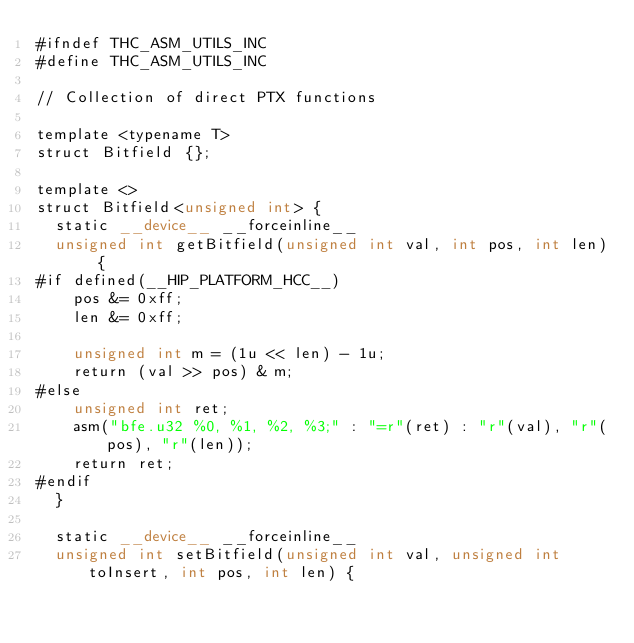Convert code to text. <code><loc_0><loc_0><loc_500><loc_500><_Cuda_>#ifndef THC_ASM_UTILS_INC
#define THC_ASM_UTILS_INC

// Collection of direct PTX functions

template <typename T>
struct Bitfield {};

template <>
struct Bitfield<unsigned int> {
  static __device__ __forceinline__
  unsigned int getBitfield(unsigned int val, int pos, int len) {
#if defined(__HIP_PLATFORM_HCC__)
    pos &= 0xff;
    len &= 0xff;

    unsigned int m = (1u << len) - 1u;
    return (val >> pos) & m;
#else
    unsigned int ret;
    asm("bfe.u32 %0, %1, %2, %3;" : "=r"(ret) : "r"(val), "r"(pos), "r"(len));
    return ret;
#endif
  }

  static __device__ __forceinline__
  unsigned int setBitfield(unsigned int val, unsigned int toInsert, int pos, int len) {</code> 